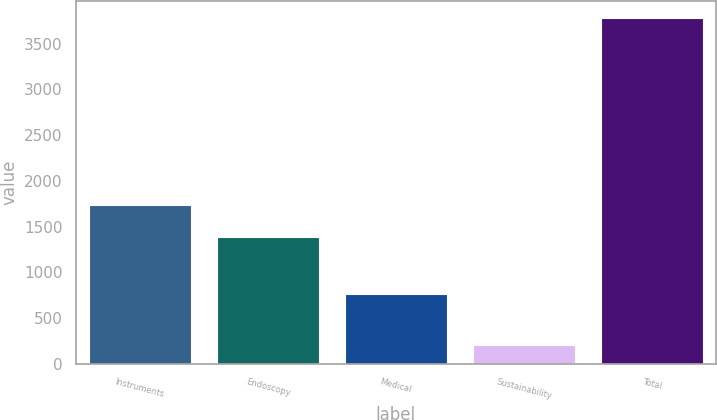<chart> <loc_0><loc_0><loc_500><loc_500><bar_chart><fcel>Instruments<fcel>Endoscopy<fcel>Medical<fcel>Sustainability<fcel>Total<nl><fcel>1739.2<fcel>1382<fcel>766<fcel>209<fcel>3781<nl></chart> 